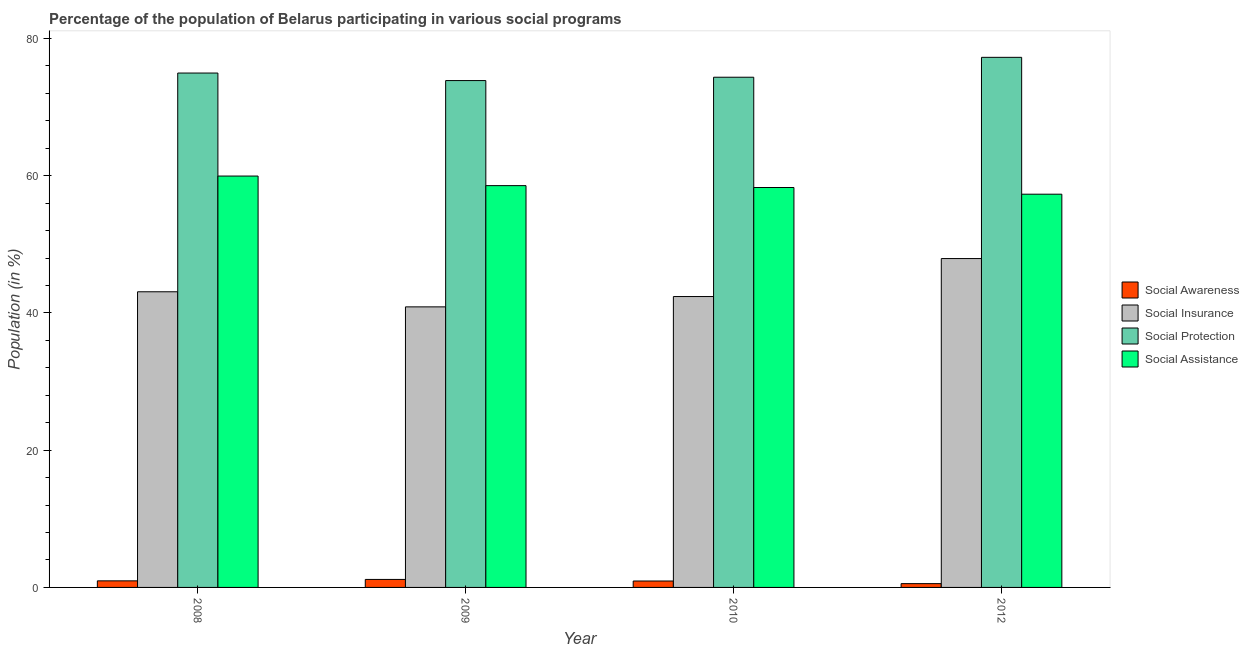How many different coloured bars are there?
Keep it short and to the point. 4. How many groups of bars are there?
Keep it short and to the point. 4. Are the number of bars on each tick of the X-axis equal?
Offer a very short reply. Yes. How many bars are there on the 2nd tick from the right?
Keep it short and to the point. 4. In how many cases, is the number of bars for a given year not equal to the number of legend labels?
Your response must be concise. 0. What is the participation of population in social insurance programs in 2010?
Ensure brevity in your answer.  42.39. Across all years, what is the maximum participation of population in social awareness programs?
Ensure brevity in your answer.  1.17. Across all years, what is the minimum participation of population in social awareness programs?
Make the answer very short. 0.55. In which year was the participation of population in social insurance programs minimum?
Keep it short and to the point. 2009. What is the total participation of population in social awareness programs in the graph?
Keep it short and to the point. 3.61. What is the difference between the participation of population in social insurance programs in 2009 and that in 2010?
Make the answer very short. -1.5. What is the difference between the participation of population in social protection programs in 2010 and the participation of population in social insurance programs in 2012?
Offer a terse response. -2.9. What is the average participation of population in social assistance programs per year?
Your answer should be compact. 58.52. What is the ratio of the participation of population in social insurance programs in 2008 to that in 2009?
Ensure brevity in your answer.  1.05. Is the participation of population in social protection programs in 2009 less than that in 2012?
Your response must be concise. Yes. Is the difference between the participation of population in social awareness programs in 2009 and 2010 greater than the difference between the participation of population in social assistance programs in 2009 and 2010?
Your answer should be compact. No. What is the difference between the highest and the second highest participation of population in social insurance programs?
Offer a terse response. 4.84. What is the difference between the highest and the lowest participation of population in social awareness programs?
Your answer should be very brief. 0.61. Is it the case that in every year, the sum of the participation of population in social insurance programs and participation of population in social awareness programs is greater than the sum of participation of population in social protection programs and participation of population in social assistance programs?
Your response must be concise. Yes. What does the 1st bar from the left in 2010 represents?
Your answer should be compact. Social Awareness. What does the 2nd bar from the right in 2012 represents?
Your answer should be very brief. Social Protection. How many years are there in the graph?
Offer a terse response. 4. What is the difference between two consecutive major ticks on the Y-axis?
Provide a short and direct response. 20. What is the title of the graph?
Offer a very short reply. Percentage of the population of Belarus participating in various social programs . What is the label or title of the Y-axis?
Make the answer very short. Population (in %). What is the Population (in %) in Social Awareness in 2008?
Keep it short and to the point. 0.96. What is the Population (in %) of Social Insurance in 2008?
Ensure brevity in your answer.  43.09. What is the Population (in %) of Social Protection in 2008?
Make the answer very short. 74.96. What is the Population (in %) of Social Assistance in 2008?
Provide a succinct answer. 59.95. What is the Population (in %) of Social Awareness in 2009?
Provide a succinct answer. 1.17. What is the Population (in %) of Social Insurance in 2009?
Offer a terse response. 40.89. What is the Population (in %) in Social Protection in 2009?
Give a very brief answer. 73.86. What is the Population (in %) of Social Assistance in 2009?
Your answer should be compact. 58.55. What is the Population (in %) in Social Awareness in 2010?
Give a very brief answer. 0.93. What is the Population (in %) of Social Insurance in 2010?
Your answer should be compact. 42.39. What is the Population (in %) of Social Protection in 2010?
Make the answer very short. 74.35. What is the Population (in %) in Social Assistance in 2010?
Make the answer very short. 58.28. What is the Population (in %) in Social Awareness in 2012?
Provide a short and direct response. 0.55. What is the Population (in %) in Social Insurance in 2012?
Give a very brief answer. 47.93. What is the Population (in %) of Social Protection in 2012?
Your answer should be very brief. 77.25. What is the Population (in %) of Social Assistance in 2012?
Your answer should be very brief. 57.3. Across all years, what is the maximum Population (in %) of Social Awareness?
Keep it short and to the point. 1.17. Across all years, what is the maximum Population (in %) in Social Insurance?
Offer a terse response. 47.93. Across all years, what is the maximum Population (in %) in Social Protection?
Your answer should be very brief. 77.25. Across all years, what is the maximum Population (in %) of Social Assistance?
Give a very brief answer. 59.95. Across all years, what is the minimum Population (in %) in Social Awareness?
Make the answer very short. 0.55. Across all years, what is the minimum Population (in %) in Social Insurance?
Provide a short and direct response. 40.89. Across all years, what is the minimum Population (in %) of Social Protection?
Provide a succinct answer. 73.86. Across all years, what is the minimum Population (in %) in Social Assistance?
Your answer should be very brief. 57.3. What is the total Population (in %) of Social Awareness in the graph?
Provide a short and direct response. 3.61. What is the total Population (in %) in Social Insurance in the graph?
Make the answer very short. 174.29. What is the total Population (in %) in Social Protection in the graph?
Give a very brief answer. 300.42. What is the total Population (in %) of Social Assistance in the graph?
Keep it short and to the point. 234.08. What is the difference between the Population (in %) in Social Awareness in 2008 and that in 2009?
Offer a terse response. -0.21. What is the difference between the Population (in %) of Social Insurance in 2008 and that in 2009?
Make the answer very short. 2.2. What is the difference between the Population (in %) in Social Protection in 2008 and that in 2009?
Provide a short and direct response. 1.1. What is the difference between the Population (in %) of Social Assistance in 2008 and that in 2009?
Give a very brief answer. 1.4. What is the difference between the Population (in %) in Social Awareness in 2008 and that in 2010?
Ensure brevity in your answer.  0.02. What is the difference between the Population (in %) of Social Insurance in 2008 and that in 2010?
Offer a terse response. 0.7. What is the difference between the Population (in %) of Social Protection in 2008 and that in 2010?
Your answer should be compact. 0.61. What is the difference between the Population (in %) of Social Assistance in 2008 and that in 2010?
Offer a very short reply. 1.67. What is the difference between the Population (in %) in Social Awareness in 2008 and that in 2012?
Provide a short and direct response. 0.4. What is the difference between the Population (in %) of Social Insurance in 2008 and that in 2012?
Your response must be concise. -4.84. What is the difference between the Population (in %) in Social Protection in 2008 and that in 2012?
Your answer should be very brief. -2.29. What is the difference between the Population (in %) in Social Assistance in 2008 and that in 2012?
Ensure brevity in your answer.  2.64. What is the difference between the Population (in %) in Social Awareness in 2009 and that in 2010?
Give a very brief answer. 0.23. What is the difference between the Population (in %) in Social Insurance in 2009 and that in 2010?
Offer a very short reply. -1.5. What is the difference between the Population (in %) in Social Protection in 2009 and that in 2010?
Make the answer very short. -0.49. What is the difference between the Population (in %) of Social Assistance in 2009 and that in 2010?
Keep it short and to the point. 0.27. What is the difference between the Population (in %) of Social Awareness in 2009 and that in 2012?
Your response must be concise. 0.61. What is the difference between the Population (in %) in Social Insurance in 2009 and that in 2012?
Give a very brief answer. -7.04. What is the difference between the Population (in %) of Social Protection in 2009 and that in 2012?
Offer a very short reply. -3.39. What is the difference between the Population (in %) of Social Assistance in 2009 and that in 2012?
Provide a short and direct response. 1.25. What is the difference between the Population (in %) in Social Awareness in 2010 and that in 2012?
Provide a short and direct response. 0.38. What is the difference between the Population (in %) of Social Insurance in 2010 and that in 2012?
Make the answer very short. -5.54. What is the difference between the Population (in %) of Social Protection in 2010 and that in 2012?
Offer a very short reply. -2.9. What is the difference between the Population (in %) in Social Assistance in 2010 and that in 2012?
Your response must be concise. 0.97. What is the difference between the Population (in %) in Social Awareness in 2008 and the Population (in %) in Social Insurance in 2009?
Offer a terse response. -39.93. What is the difference between the Population (in %) of Social Awareness in 2008 and the Population (in %) of Social Protection in 2009?
Your response must be concise. -72.9. What is the difference between the Population (in %) of Social Awareness in 2008 and the Population (in %) of Social Assistance in 2009?
Offer a terse response. -57.59. What is the difference between the Population (in %) in Social Insurance in 2008 and the Population (in %) in Social Protection in 2009?
Ensure brevity in your answer.  -30.78. What is the difference between the Population (in %) of Social Insurance in 2008 and the Population (in %) of Social Assistance in 2009?
Provide a short and direct response. -15.47. What is the difference between the Population (in %) in Social Protection in 2008 and the Population (in %) in Social Assistance in 2009?
Your answer should be very brief. 16.41. What is the difference between the Population (in %) in Social Awareness in 2008 and the Population (in %) in Social Insurance in 2010?
Provide a succinct answer. -41.43. What is the difference between the Population (in %) of Social Awareness in 2008 and the Population (in %) of Social Protection in 2010?
Keep it short and to the point. -73.39. What is the difference between the Population (in %) in Social Awareness in 2008 and the Population (in %) in Social Assistance in 2010?
Give a very brief answer. -57.32. What is the difference between the Population (in %) in Social Insurance in 2008 and the Population (in %) in Social Protection in 2010?
Make the answer very short. -31.26. What is the difference between the Population (in %) in Social Insurance in 2008 and the Population (in %) in Social Assistance in 2010?
Your answer should be very brief. -15.19. What is the difference between the Population (in %) of Social Protection in 2008 and the Population (in %) of Social Assistance in 2010?
Your answer should be compact. 16.68. What is the difference between the Population (in %) in Social Awareness in 2008 and the Population (in %) in Social Insurance in 2012?
Offer a very short reply. -46.97. What is the difference between the Population (in %) of Social Awareness in 2008 and the Population (in %) of Social Protection in 2012?
Offer a very short reply. -76.29. What is the difference between the Population (in %) of Social Awareness in 2008 and the Population (in %) of Social Assistance in 2012?
Provide a succinct answer. -56.35. What is the difference between the Population (in %) of Social Insurance in 2008 and the Population (in %) of Social Protection in 2012?
Give a very brief answer. -34.16. What is the difference between the Population (in %) in Social Insurance in 2008 and the Population (in %) in Social Assistance in 2012?
Offer a terse response. -14.22. What is the difference between the Population (in %) of Social Protection in 2008 and the Population (in %) of Social Assistance in 2012?
Your answer should be very brief. 17.66. What is the difference between the Population (in %) in Social Awareness in 2009 and the Population (in %) in Social Insurance in 2010?
Your response must be concise. -41.22. What is the difference between the Population (in %) in Social Awareness in 2009 and the Population (in %) in Social Protection in 2010?
Offer a very short reply. -73.18. What is the difference between the Population (in %) of Social Awareness in 2009 and the Population (in %) of Social Assistance in 2010?
Your response must be concise. -57.11. What is the difference between the Population (in %) of Social Insurance in 2009 and the Population (in %) of Social Protection in 2010?
Offer a terse response. -33.47. What is the difference between the Population (in %) of Social Insurance in 2009 and the Population (in %) of Social Assistance in 2010?
Offer a terse response. -17.39. What is the difference between the Population (in %) in Social Protection in 2009 and the Population (in %) in Social Assistance in 2010?
Make the answer very short. 15.58. What is the difference between the Population (in %) in Social Awareness in 2009 and the Population (in %) in Social Insurance in 2012?
Give a very brief answer. -46.76. What is the difference between the Population (in %) of Social Awareness in 2009 and the Population (in %) of Social Protection in 2012?
Ensure brevity in your answer.  -76.08. What is the difference between the Population (in %) in Social Awareness in 2009 and the Population (in %) in Social Assistance in 2012?
Your answer should be very brief. -56.14. What is the difference between the Population (in %) in Social Insurance in 2009 and the Population (in %) in Social Protection in 2012?
Your response must be concise. -36.37. What is the difference between the Population (in %) in Social Insurance in 2009 and the Population (in %) in Social Assistance in 2012?
Your answer should be compact. -16.42. What is the difference between the Population (in %) in Social Protection in 2009 and the Population (in %) in Social Assistance in 2012?
Make the answer very short. 16.56. What is the difference between the Population (in %) of Social Awareness in 2010 and the Population (in %) of Social Insurance in 2012?
Keep it short and to the point. -46.99. What is the difference between the Population (in %) of Social Awareness in 2010 and the Population (in %) of Social Protection in 2012?
Offer a very short reply. -76.32. What is the difference between the Population (in %) in Social Awareness in 2010 and the Population (in %) in Social Assistance in 2012?
Offer a terse response. -56.37. What is the difference between the Population (in %) of Social Insurance in 2010 and the Population (in %) of Social Protection in 2012?
Your answer should be very brief. -34.86. What is the difference between the Population (in %) in Social Insurance in 2010 and the Population (in %) in Social Assistance in 2012?
Make the answer very short. -14.92. What is the difference between the Population (in %) in Social Protection in 2010 and the Population (in %) in Social Assistance in 2012?
Offer a very short reply. 17.05. What is the average Population (in %) of Social Awareness per year?
Provide a succinct answer. 0.9. What is the average Population (in %) in Social Insurance per year?
Your answer should be compact. 43.57. What is the average Population (in %) of Social Protection per year?
Make the answer very short. 75.11. What is the average Population (in %) in Social Assistance per year?
Provide a short and direct response. 58.52. In the year 2008, what is the difference between the Population (in %) in Social Awareness and Population (in %) in Social Insurance?
Give a very brief answer. -42.13. In the year 2008, what is the difference between the Population (in %) in Social Awareness and Population (in %) in Social Protection?
Your answer should be very brief. -74. In the year 2008, what is the difference between the Population (in %) of Social Awareness and Population (in %) of Social Assistance?
Offer a terse response. -58.99. In the year 2008, what is the difference between the Population (in %) in Social Insurance and Population (in %) in Social Protection?
Make the answer very short. -31.88. In the year 2008, what is the difference between the Population (in %) of Social Insurance and Population (in %) of Social Assistance?
Provide a short and direct response. -16.86. In the year 2008, what is the difference between the Population (in %) in Social Protection and Population (in %) in Social Assistance?
Provide a succinct answer. 15.01. In the year 2009, what is the difference between the Population (in %) in Social Awareness and Population (in %) in Social Insurance?
Give a very brief answer. -39.72. In the year 2009, what is the difference between the Population (in %) in Social Awareness and Population (in %) in Social Protection?
Make the answer very short. -72.7. In the year 2009, what is the difference between the Population (in %) in Social Awareness and Population (in %) in Social Assistance?
Keep it short and to the point. -57.39. In the year 2009, what is the difference between the Population (in %) in Social Insurance and Population (in %) in Social Protection?
Your answer should be compact. -32.98. In the year 2009, what is the difference between the Population (in %) of Social Insurance and Population (in %) of Social Assistance?
Provide a succinct answer. -17.67. In the year 2009, what is the difference between the Population (in %) of Social Protection and Population (in %) of Social Assistance?
Your answer should be very brief. 15.31. In the year 2010, what is the difference between the Population (in %) in Social Awareness and Population (in %) in Social Insurance?
Offer a terse response. -41.46. In the year 2010, what is the difference between the Population (in %) of Social Awareness and Population (in %) of Social Protection?
Your answer should be very brief. -73.42. In the year 2010, what is the difference between the Population (in %) in Social Awareness and Population (in %) in Social Assistance?
Your answer should be very brief. -57.34. In the year 2010, what is the difference between the Population (in %) in Social Insurance and Population (in %) in Social Protection?
Your answer should be very brief. -31.96. In the year 2010, what is the difference between the Population (in %) in Social Insurance and Population (in %) in Social Assistance?
Provide a short and direct response. -15.89. In the year 2010, what is the difference between the Population (in %) of Social Protection and Population (in %) of Social Assistance?
Ensure brevity in your answer.  16.07. In the year 2012, what is the difference between the Population (in %) in Social Awareness and Population (in %) in Social Insurance?
Make the answer very short. -47.37. In the year 2012, what is the difference between the Population (in %) in Social Awareness and Population (in %) in Social Protection?
Keep it short and to the point. -76.7. In the year 2012, what is the difference between the Population (in %) of Social Awareness and Population (in %) of Social Assistance?
Provide a succinct answer. -56.75. In the year 2012, what is the difference between the Population (in %) of Social Insurance and Population (in %) of Social Protection?
Make the answer very short. -29.32. In the year 2012, what is the difference between the Population (in %) in Social Insurance and Population (in %) in Social Assistance?
Offer a very short reply. -9.38. In the year 2012, what is the difference between the Population (in %) of Social Protection and Population (in %) of Social Assistance?
Ensure brevity in your answer.  19.95. What is the ratio of the Population (in %) of Social Awareness in 2008 to that in 2009?
Offer a very short reply. 0.82. What is the ratio of the Population (in %) of Social Insurance in 2008 to that in 2009?
Provide a succinct answer. 1.05. What is the ratio of the Population (in %) in Social Protection in 2008 to that in 2009?
Your answer should be very brief. 1.01. What is the ratio of the Population (in %) of Social Assistance in 2008 to that in 2009?
Offer a very short reply. 1.02. What is the ratio of the Population (in %) of Social Awareness in 2008 to that in 2010?
Provide a short and direct response. 1.02. What is the ratio of the Population (in %) in Social Insurance in 2008 to that in 2010?
Ensure brevity in your answer.  1.02. What is the ratio of the Population (in %) in Social Protection in 2008 to that in 2010?
Your answer should be very brief. 1.01. What is the ratio of the Population (in %) in Social Assistance in 2008 to that in 2010?
Offer a very short reply. 1.03. What is the ratio of the Population (in %) in Social Awareness in 2008 to that in 2012?
Provide a succinct answer. 1.73. What is the ratio of the Population (in %) in Social Insurance in 2008 to that in 2012?
Provide a short and direct response. 0.9. What is the ratio of the Population (in %) of Social Protection in 2008 to that in 2012?
Your response must be concise. 0.97. What is the ratio of the Population (in %) of Social Assistance in 2008 to that in 2012?
Your response must be concise. 1.05. What is the ratio of the Population (in %) in Social Awareness in 2009 to that in 2010?
Offer a very short reply. 1.25. What is the ratio of the Population (in %) of Social Insurance in 2009 to that in 2010?
Offer a terse response. 0.96. What is the ratio of the Population (in %) in Social Assistance in 2009 to that in 2010?
Your answer should be very brief. 1. What is the ratio of the Population (in %) of Social Awareness in 2009 to that in 2012?
Offer a terse response. 2.11. What is the ratio of the Population (in %) of Social Insurance in 2009 to that in 2012?
Offer a terse response. 0.85. What is the ratio of the Population (in %) in Social Protection in 2009 to that in 2012?
Keep it short and to the point. 0.96. What is the ratio of the Population (in %) in Social Assistance in 2009 to that in 2012?
Ensure brevity in your answer.  1.02. What is the ratio of the Population (in %) of Social Awareness in 2010 to that in 2012?
Ensure brevity in your answer.  1.69. What is the ratio of the Population (in %) of Social Insurance in 2010 to that in 2012?
Offer a terse response. 0.88. What is the ratio of the Population (in %) in Social Protection in 2010 to that in 2012?
Ensure brevity in your answer.  0.96. What is the ratio of the Population (in %) of Social Assistance in 2010 to that in 2012?
Provide a succinct answer. 1.02. What is the difference between the highest and the second highest Population (in %) of Social Awareness?
Keep it short and to the point. 0.21. What is the difference between the highest and the second highest Population (in %) in Social Insurance?
Offer a very short reply. 4.84. What is the difference between the highest and the second highest Population (in %) in Social Protection?
Provide a succinct answer. 2.29. What is the difference between the highest and the second highest Population (in %) in Social Assistance?
Your answer should be compact. 1.4. What is the difference between the highest and the lowest Population (in %) in Social Awareness?
Your answer should be very brief. 0.61. What is the difference between the highest and the lowest Population (in %) in Social Insurance?
Offer a very short reply. 7.04. What is the difference between the highest and the lowest Population (in %) in Social Protection?
Provide a short and direct response. 3.39. What is the difference between the highest and the lowest Population (in %) of Social Assistance?
Make the answer very short. 2.64. 